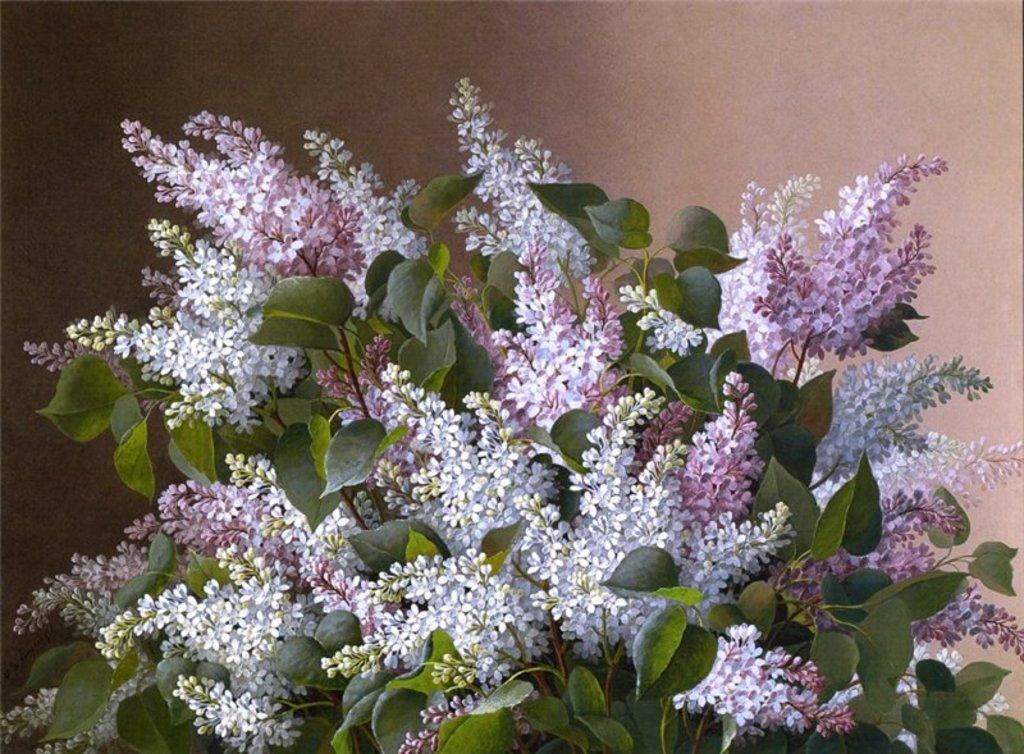What is located in the center of the image? There are flowers and leaves in the center of the image. Can you describe the background of the image? There is a wall visible in the background of the image. What type of body is visible in the image? There is no body present in the image; it features flowers and leaves in the center and a wall in the background. What request can be seen being made in the image? There is no request present in the image; it features flowers and leaves in the center and a wall in the background. 